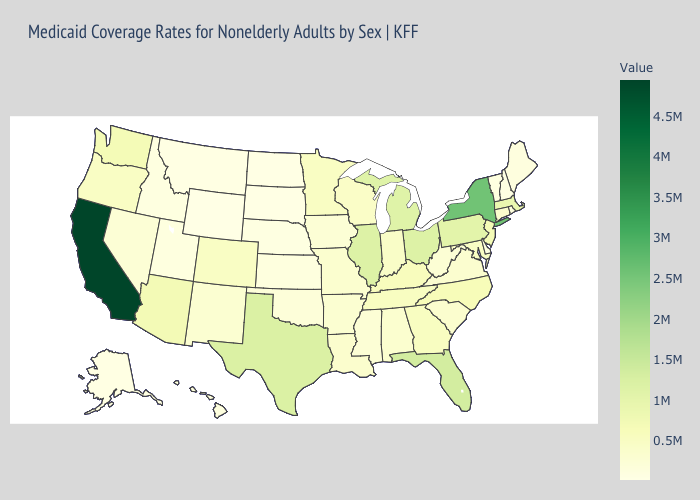Among the states that border New Jersey , does Pennsylvania have the highest value?
Keep it brief. No. Does Utah have the highest value in the USA?
Write a very short answer. No. 